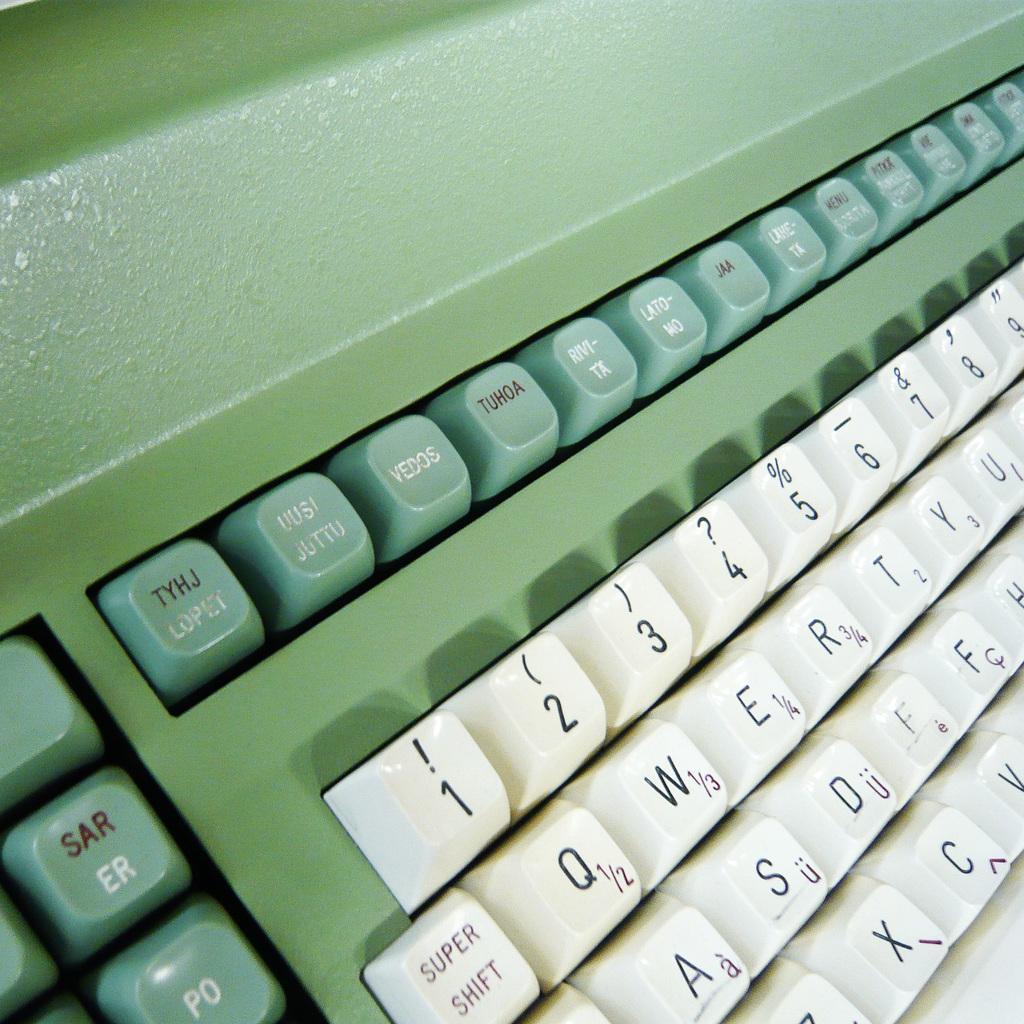<image>
Write a terse but informative summary of the picture. a type writer with green and white colored keys with the key super shift on the bottom. 